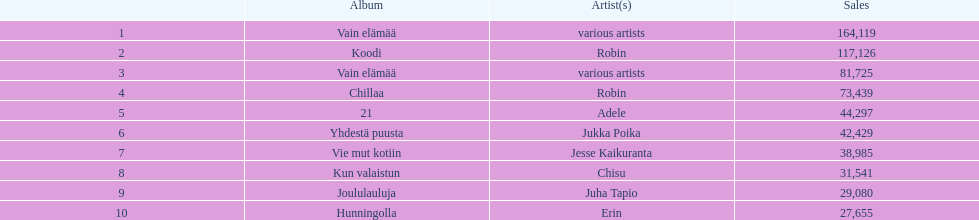Which was more successful in sales, hunningolla or vain elamaa? Vain elämää. 